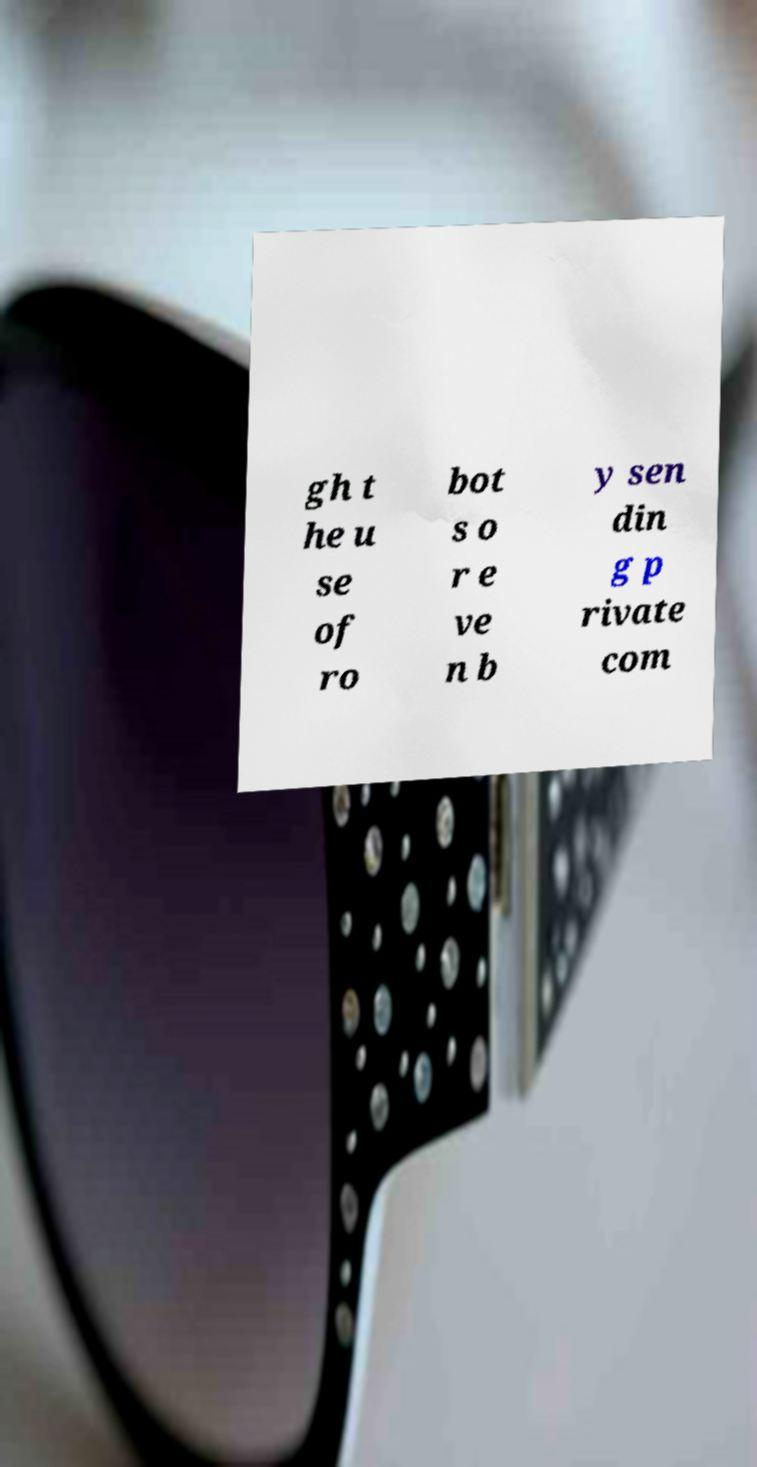Please identify and transcribe the text found in this image. gh t he u se of ro bot s o r e ve n b y sen din g p rivate com 